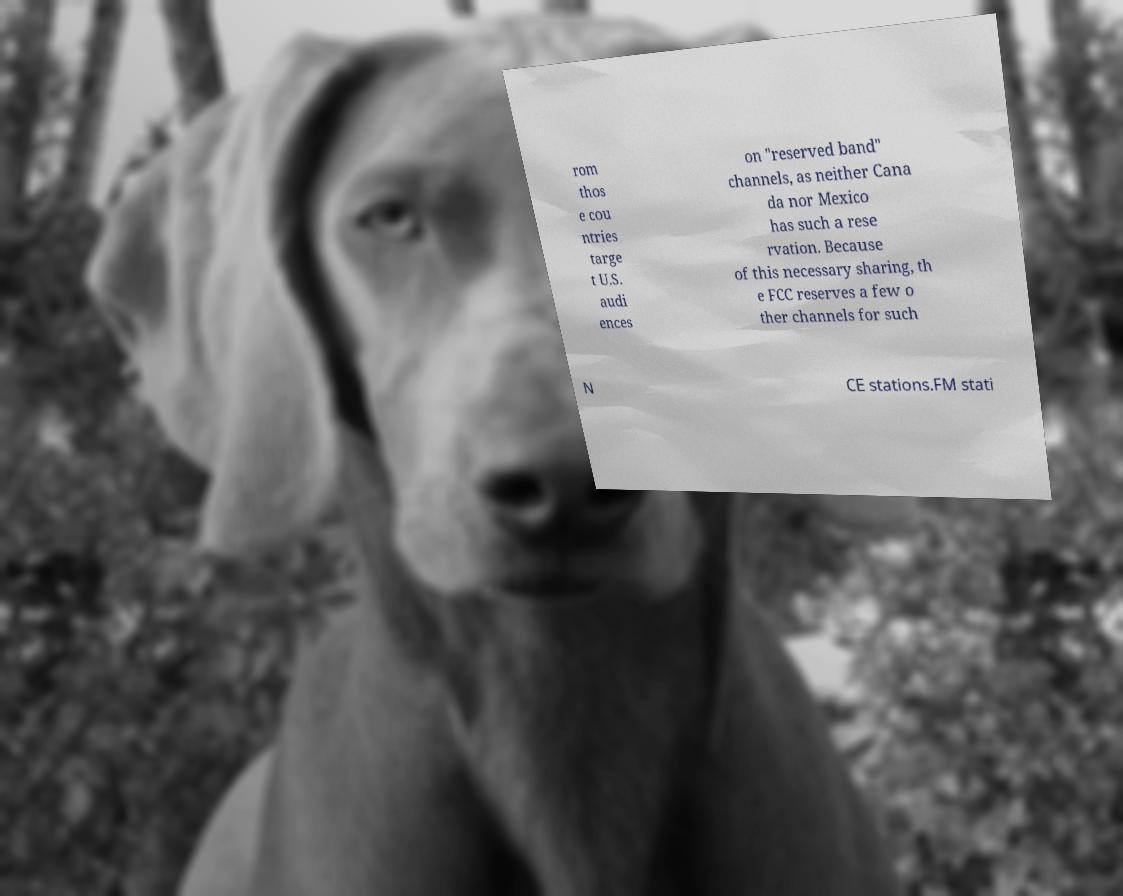Could you extract and type out the text from this image? rom thos e cou ntries targe t U.S. audi ences on "reserved band" channels, as neither Cana da nor Mexico has such a rese rvation. Because of this necessary sharing, th e FCC reserves a few o ther channels for such N CE stations.FM stati 